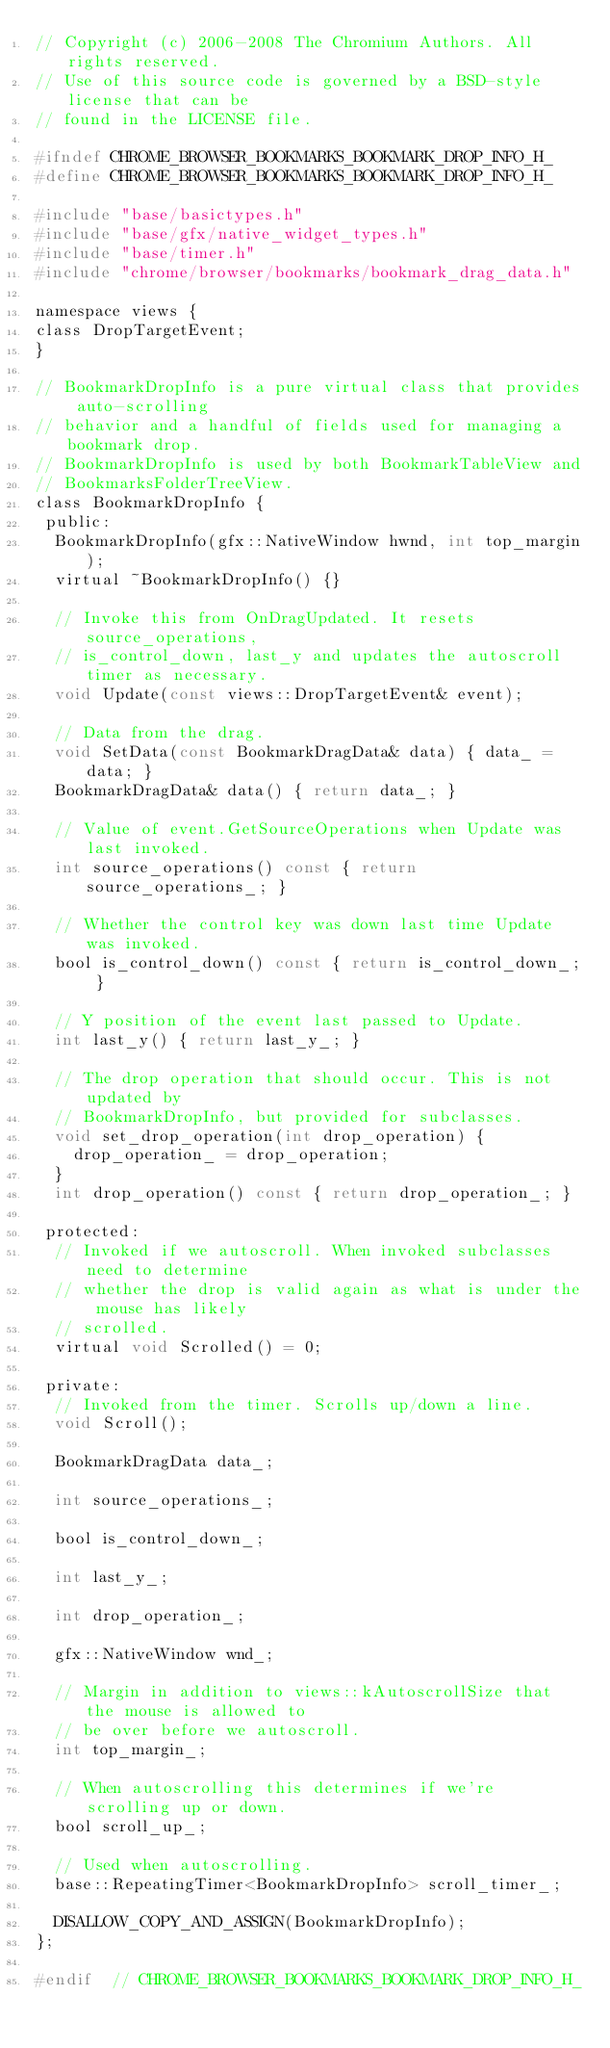Convert code to text. <code><loc_0><loc_0><loc_500><loc_500><_C_>// Copyright (c) 2006-2008 The Chromium Authors. All rights reserved.
// Use of this source code is governed by a BSD-style license that can be
// found in the LICENSE file.

#ifndef CHROME_BROWSER_BOOKMARKS_BOOKMARK_DROP_INFO_H_
#define CHROME_BROWSER_BOOKMARKS_BOOKMARK_DROP_INFO_H_

#include "base/basictypes.h"
#include "base/gfx/native_widget_types.h"
#include "base/timer.h"
#include "chrome/browser/bookmarks/bookmark_drag_data.h"

namespace views {
class DropTargetEvent;
}

// BookmarkDropInfo is a pure virtual class that provides auto-scrolling
// behavior and a handful of fields used for managing a bookmark drop.
// BookmarkDropInfo is used by both BookmarkTableView and
// BookmarksFolderTreeView.
class BookmarkDropInfo {
 public:
  BookmarkDropInfo(gfx::NativeWindow hwnd, int top_margin);
  virtual ~BookmarkDropInfo() {}

  // Invoke this from OnDragUpdated. It resets source_operations,
  // is_control_down, last_y and updates the autoscroll timer as necessary.
  void Update(const views::DropTargetEvent& event);

  // Data from the drag.
  void SetData(const BookmarkDragData& data) { data_ = data; }
  BookmarkDragData& data() { return data_; }

  // Value of event.GetSourceOperations when Update was last invoked.
  int source_operations() const { return source_operations_; }

  // Whether the control key was down last time Update was invoked.
  bool is_control_down() const { return is_control_down_; }

  // Y position of the event last passed to Update.
  int last_y() { return last_y_; }

  // The drop operation that should occur. This is not updated by
  // BookmarkDropInfo, but provided for subclasses.
  void set_drop_operation(int drop_operation) {
    drop_operation_ = drop_operation;
  }
  int drop_operation() const { return drop_operation_; }

 protected:
  // Invoked if we autoscroll. When invoked subclasses need to determine
  // whether the drop is valid again as what is under the mouse has likely
  // scrolled.
  virtual void Scrolled() = 0;

 private:
  // Invoked from the timer. Scrolls up/down a line.
  void Scroll();

  BookmarkDragData data_;

  int source_operations_;

  bool is_control_down_;

  int last_y_;

  int drop_operation_;

  gfx::NativeWindow wnd_;

  // Margin in addition to views::kAutoscrollSize that the mouse is allowed to
  // be over before we autoscroll.
  int top_margin_;

  // When autoscrolling this determines if we're scrolling up or down.
  bool scroll_up_;

  // Used when autoscrolling.
  base::RepeatingTimer<BookmarkDropInfo> scroll_timer_;

  DISALLOW_COPY_AND_ASSIGN(BookmarkDropInfo);
};

#endif  // CHROME_BROWSER_BOOKMARKS_BOOKMARK_DROP_INFO_H_
</code> 